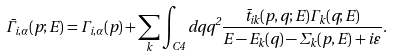<formula> <loc_0><loc_0><loc_500><loc_500>\bar { \Gamma } _ { i , \alpha } ( p ; E ) = \Gamma _ { i , \alpha } ( p ) + \sum _ { k } \int _ { C 4 } d q q ^ { 2 } \frac { \bar { t } _ { i k } ( p , q ; E ) \Gamma _ { k } ( q ; E ) } { E - E _ { k } ( q ) - \Sigma _ { k } ( p , E ) + i \varepsilon } .</formula> 